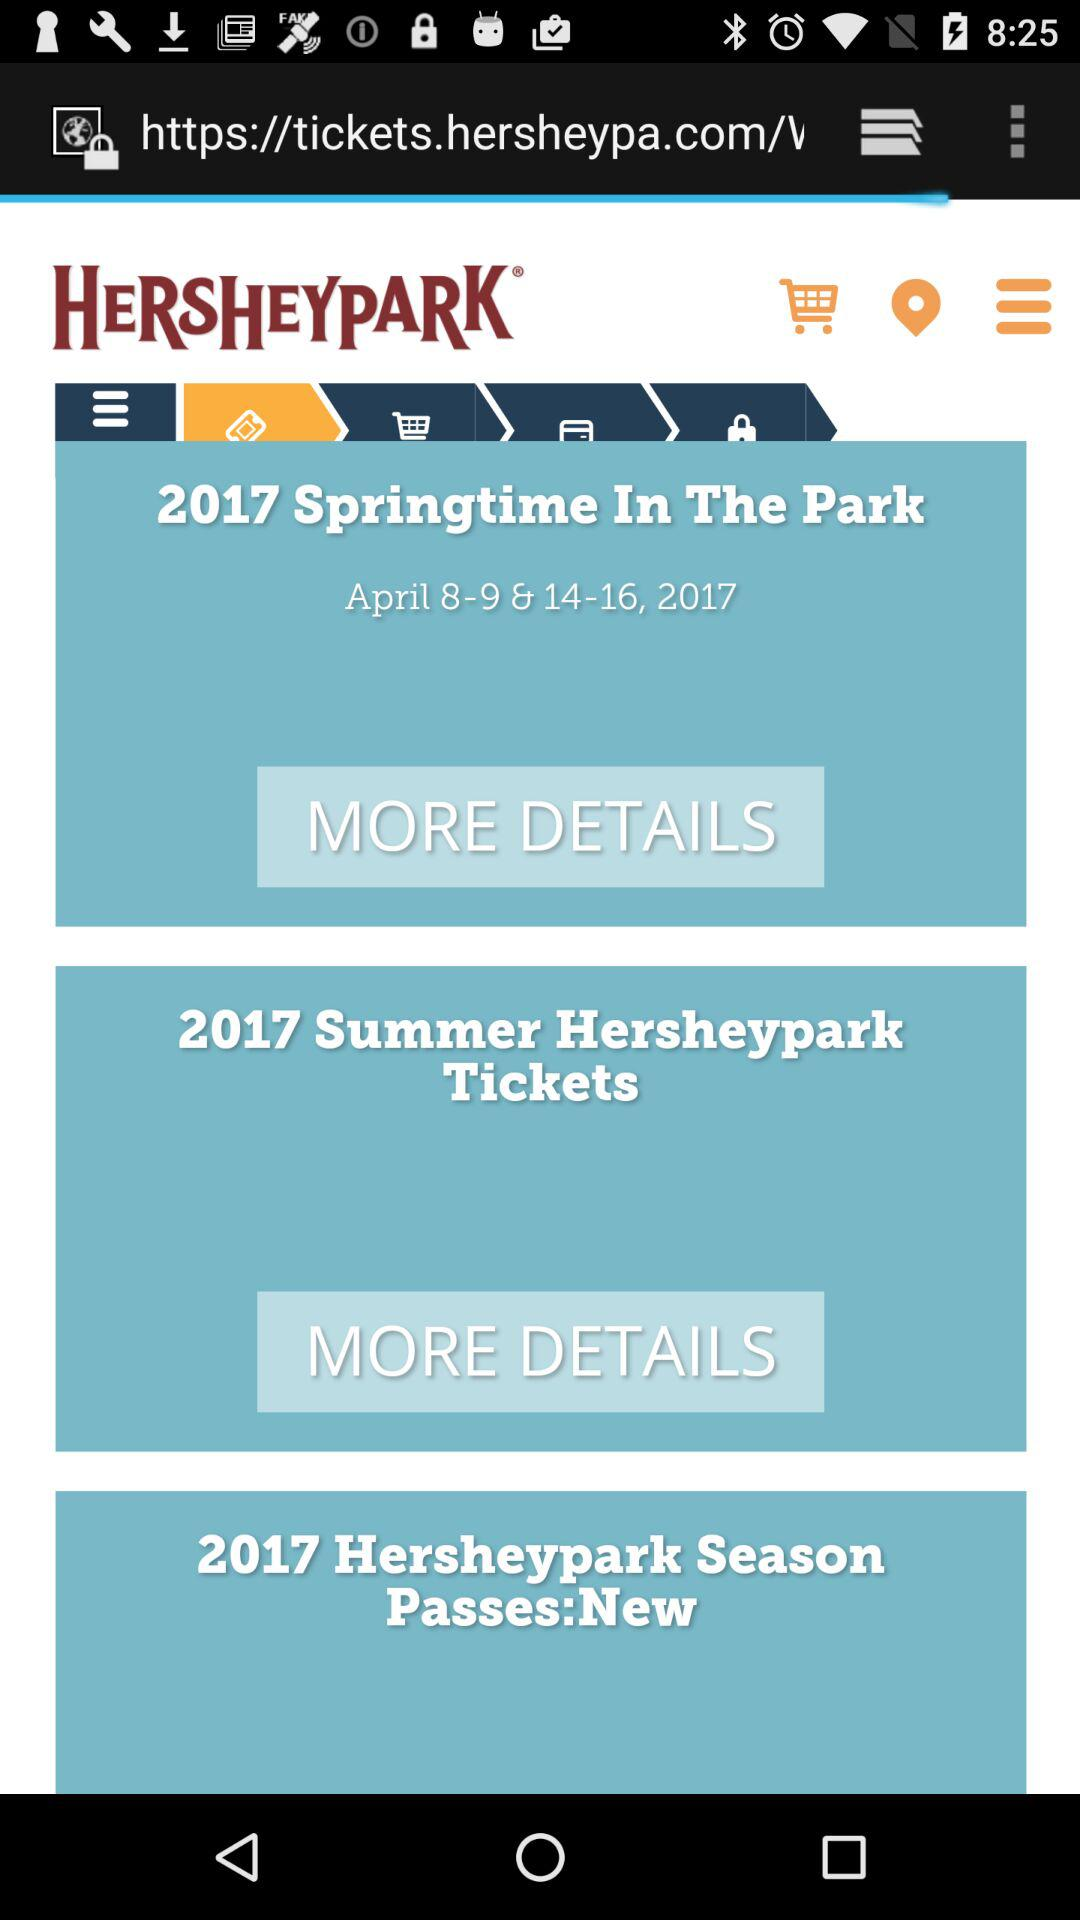What is the scheduled date of "2017 Springtime In The Park"? The scheduled dates of "2017 Springtime In The Park" are from April 8, 2017 to April 9, 2017 and April 14, 2017 to April 16, 2017. 